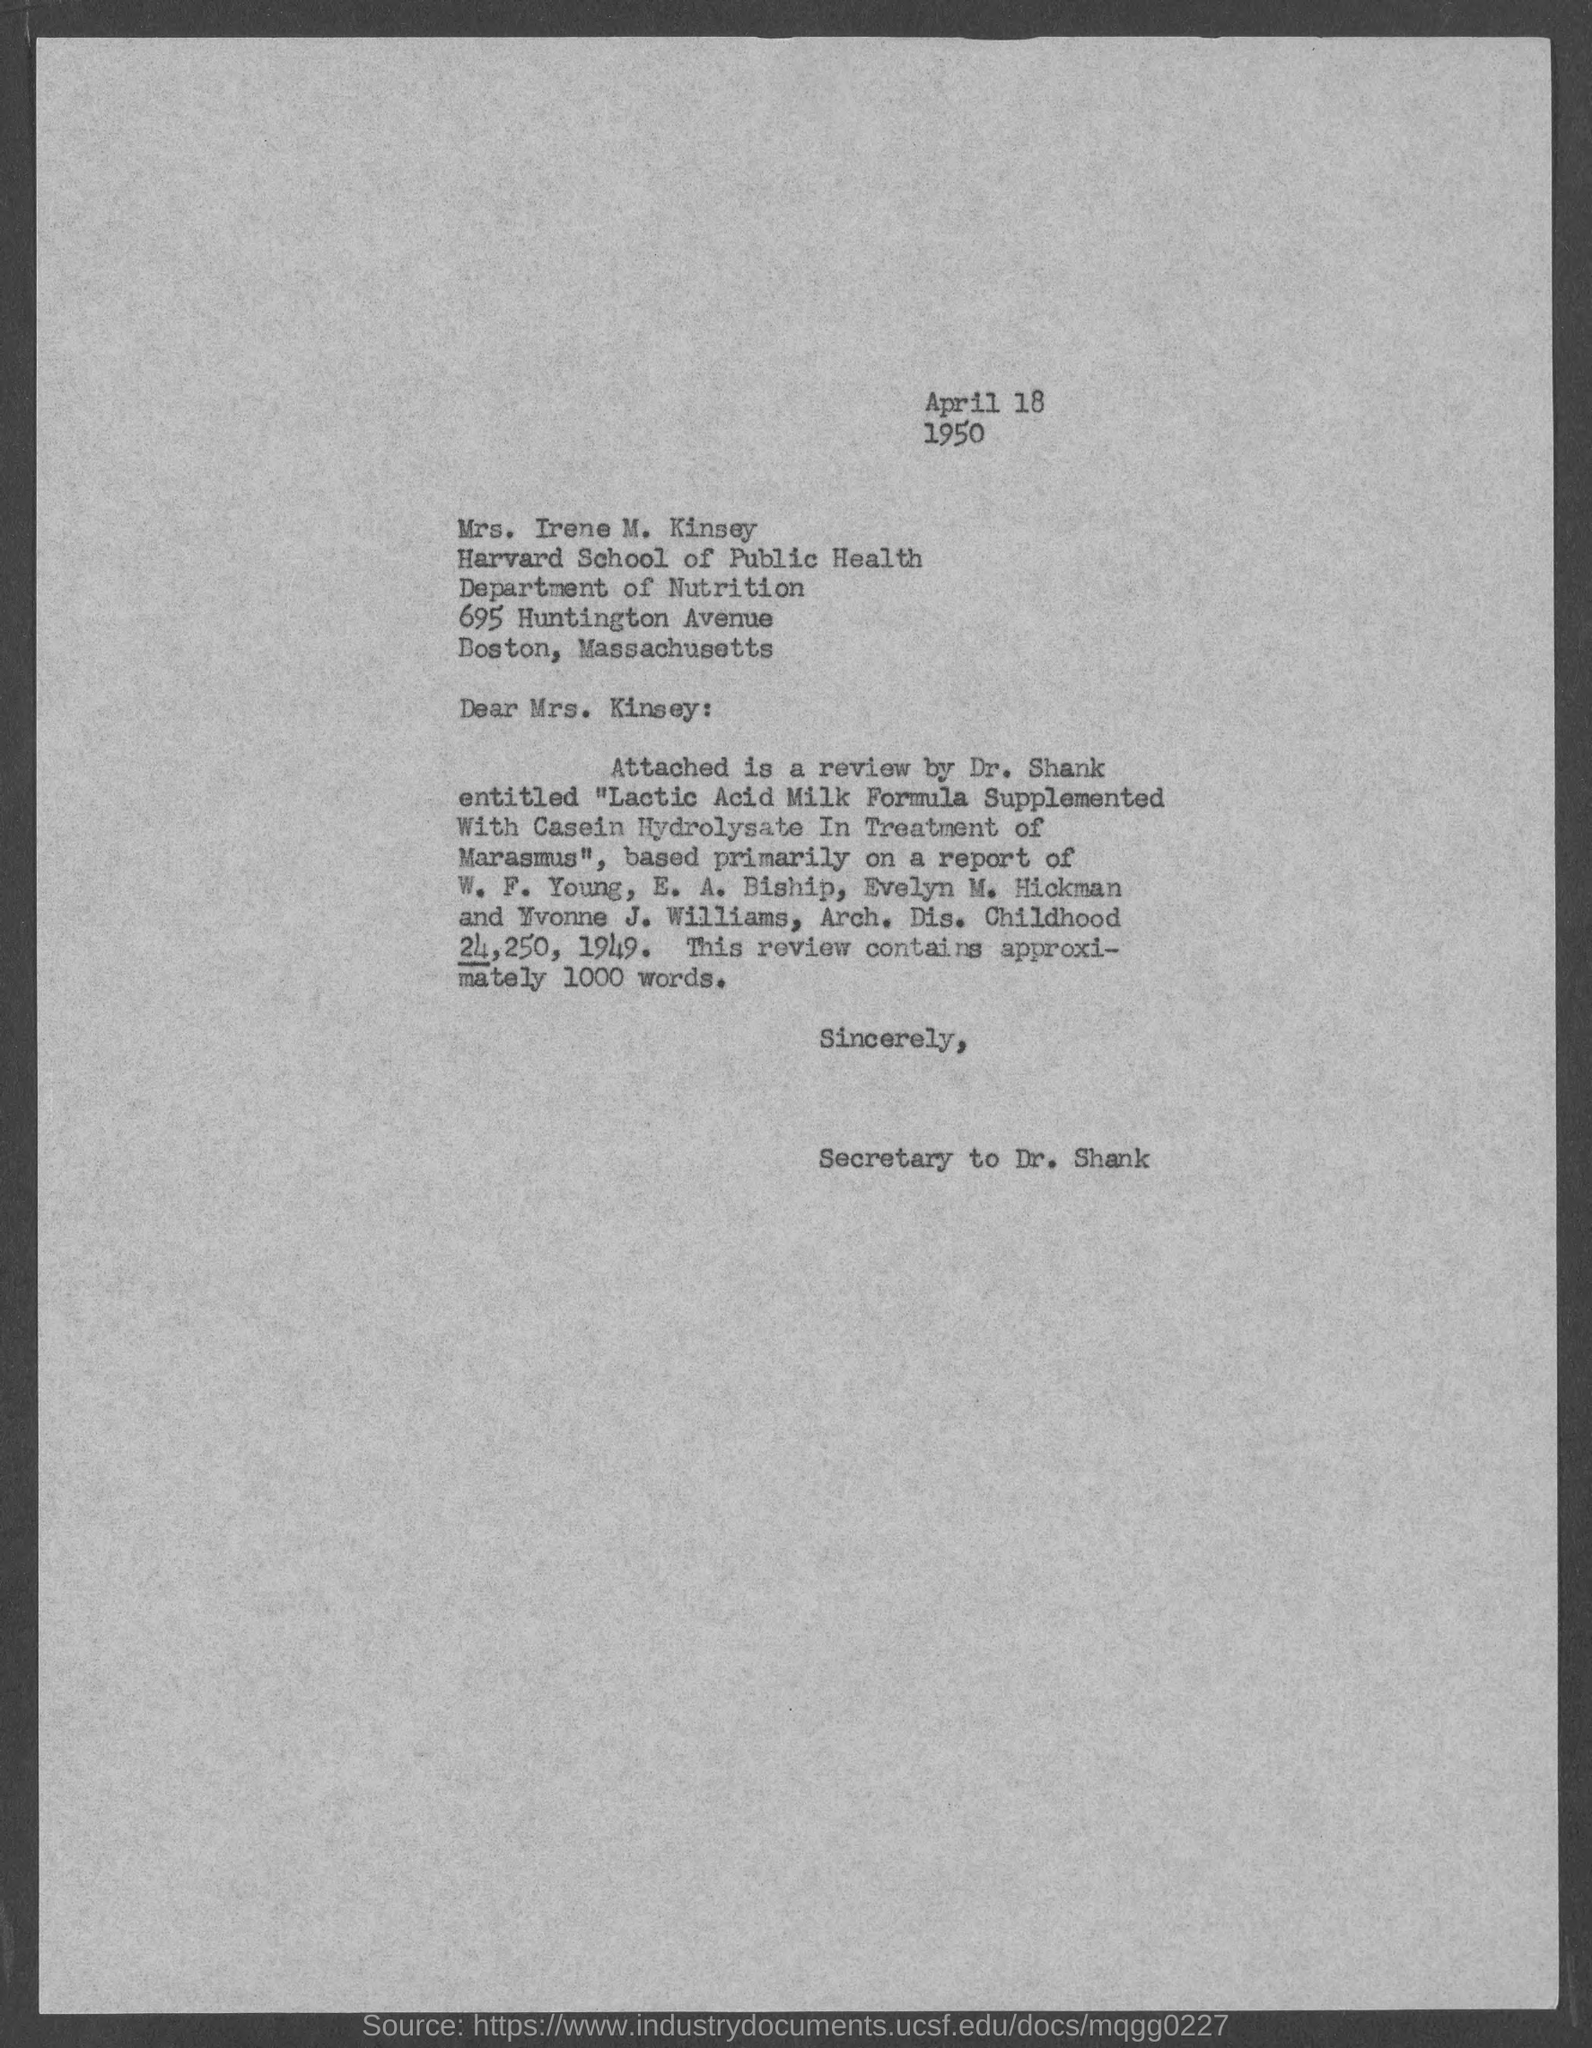What is the date?
Your answer should be compact. April 18, 1950. What is the salutation of this letter?
Offer a very short reply. Dear Mrs. Kinsey. 